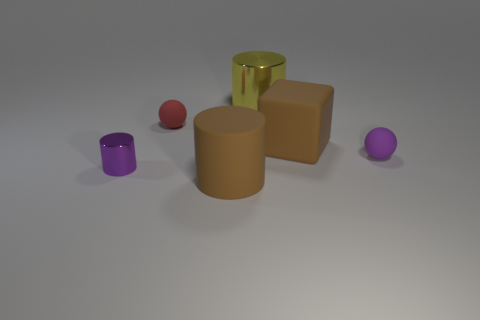The big brown matte thing that is in front of the tiny object on the right side of the large metallic thing is what shape?
Give a very brief answer. Cylinder. There is a tiny purple object that is made of the same material as the red sphere; what shape is it?
Keep it short and to the point. Sphere. There is a purple object on the left side of the small purple matte ball; does it have the same size as the matte ball that is left of the purple ball?
Your answer should be very brief. Yes. What shape is the large rubber object to the left of the big yellow metal thing?
Your answer should be very brief. Cylinder. The tiny cylinder has what color?
Provide a short and direct response. Purple. Is the size of the block the same as the ball that is on the left side of the big metal thing?
Offer a very short reply. No. What number of matte objects are either blocks or small yellow objects?
Your response must be concise. 1. Is there anything else that has the same material as the tiny red ball?
Provide a succinct answer. Yes. There is a large cube; is it the same color as the cylinder that is behind the small metal cylinder?
Offer a very short reply. No. What is the shape of the yellow thing?
Make the answer very short. Cylinder. 